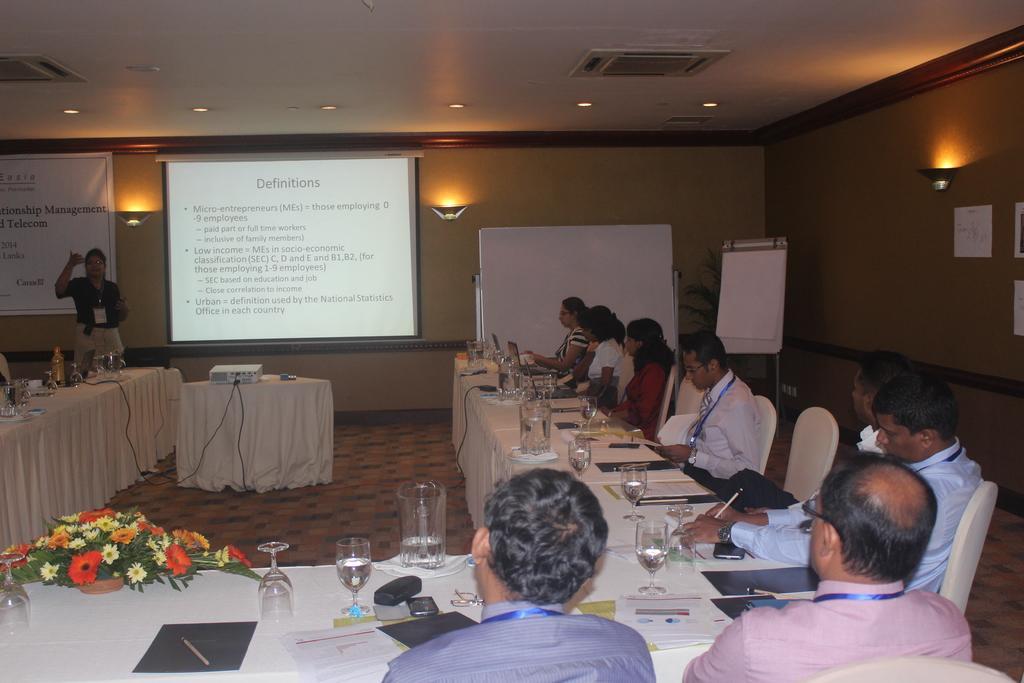Describe this image in one or two sentences. In this image I can see number of persons are sitting on white colored chairs in front of the white colored desk. On the desk I can see few flowers, few glasses, few glass jars, few papers, a bottle and few other objects. In the background I can see a person standing, a white colored projector, few wires, few boards, a banner, a screen, the ceiling, few lights to the ceiling, the wall and few lights to the wall. 